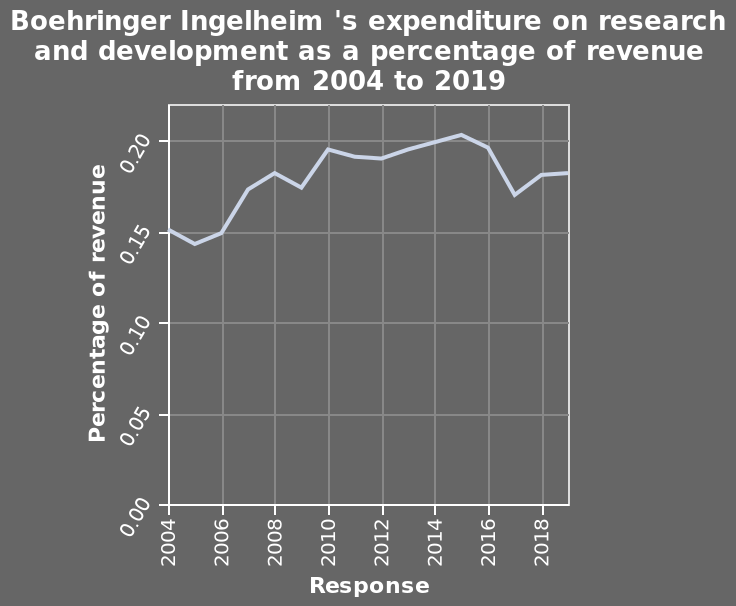<image>
please describe the details of the chart This is a line diagram named Boehringer Ingelheim 's expenditure on research and development as a percentage of revenue from 2004 to 2019. A linear scale with a minimum of 2004 and a maximum of 2018 can be seen on the x-axis, marked Response. There is a linear scale from 0.00 to 0.20 along the y-axis, marked Percentage of revenue. What is the name of the line diagram?  The line diagram is named Boehringer Ingelheim's expenditure on research and development as a percentage of revenue. 